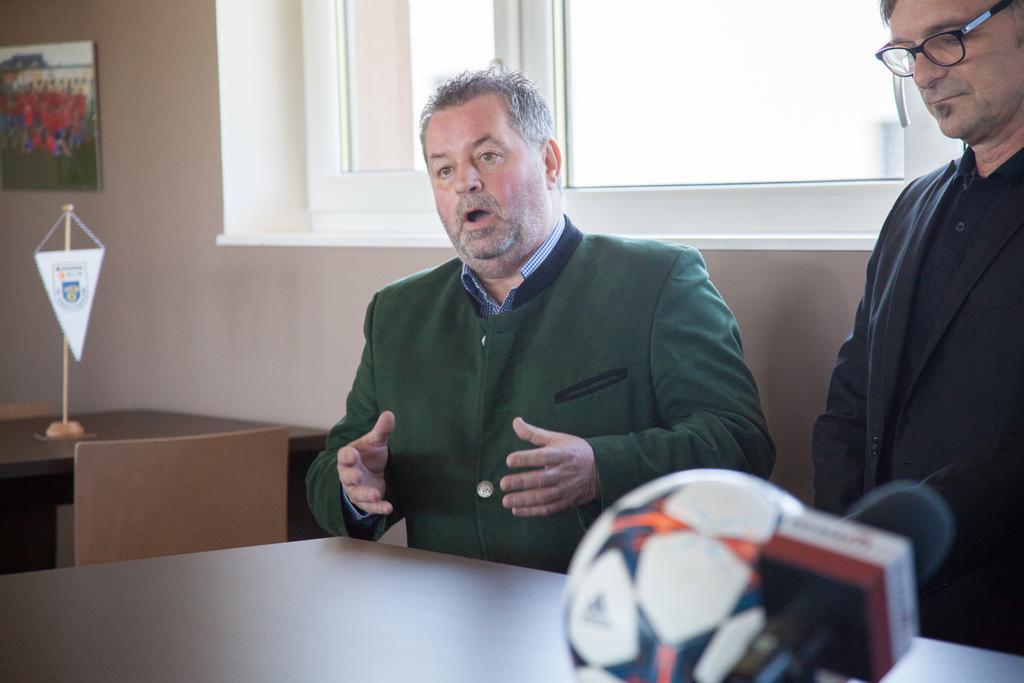Can you describe this image briefly? In this image we can see two person and one among them is talking and there is a table in front of them and on the table, we can see a ball and mic. To the side there is an object on the table and we can see the wall with a photo frame and the window. 